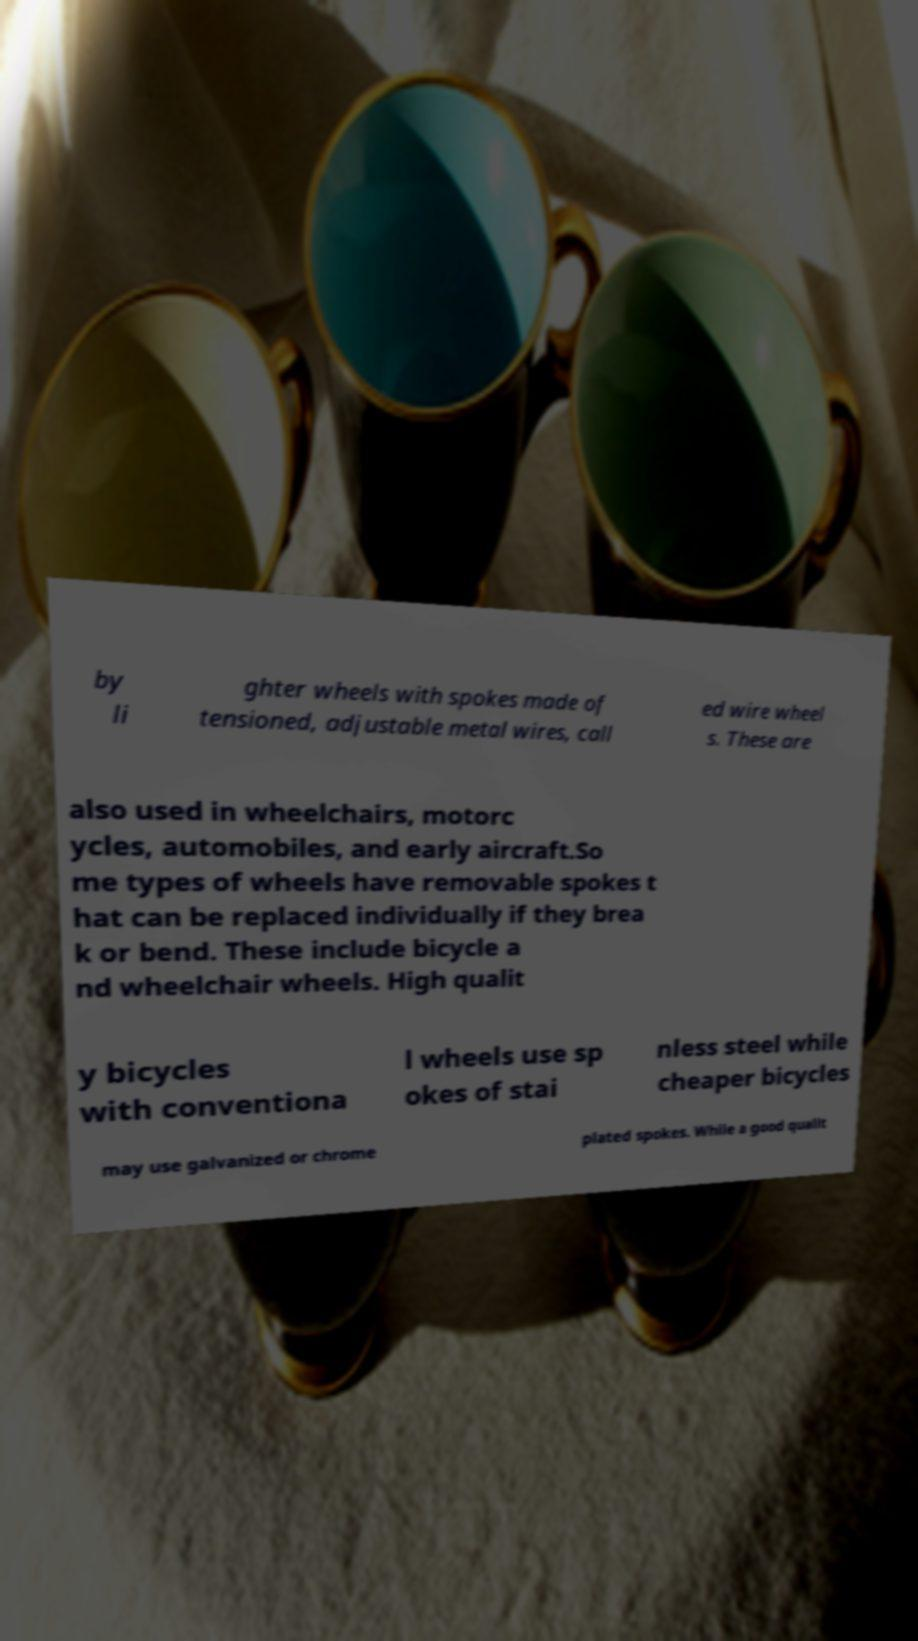Could you assist in decoding the text presented in this image and type it out clearly? by li ghter wheels with spokes made of tensioned, adjustable metal wires, call ed wire wheel s. These are also used in wheelchairs, motorc ycles, automobiles, and early aircraft.So me types of wheels have removable spokes t hat can be replaced individually if they brea k or bend. These include bicycle a nd wheelchair wheels. High qualit y bicycles with conventiona l wheels use sp okes of stai nless steel while cheaper bicycles may use galvanized or chrome plated spokes. While a good qualit 